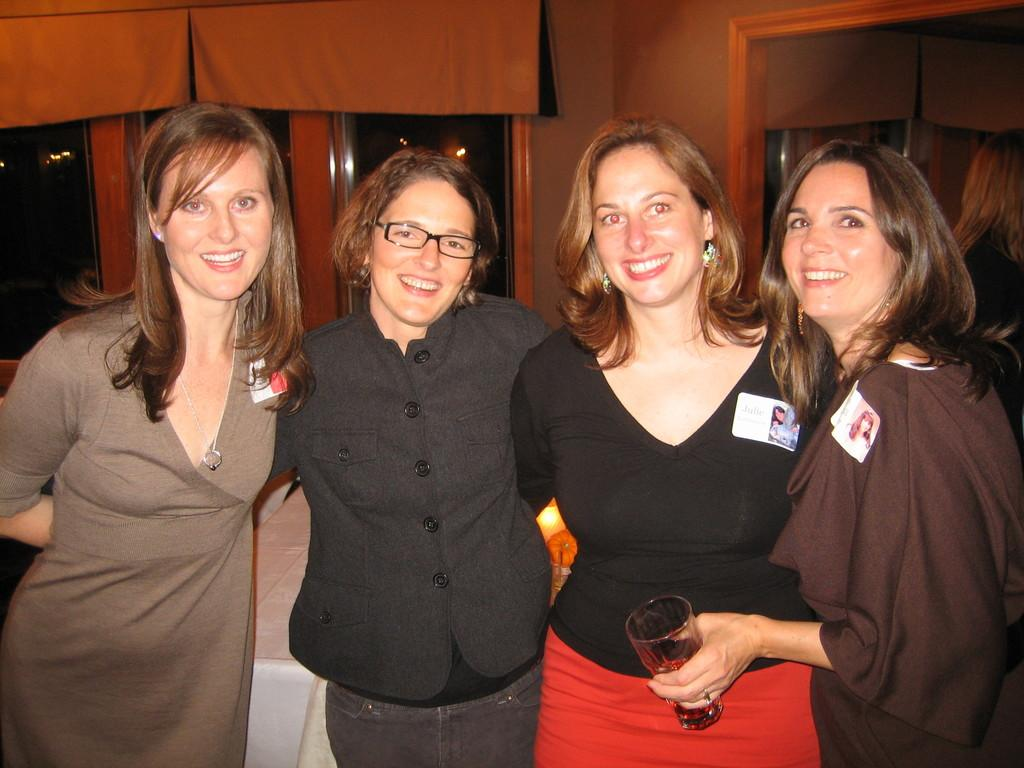How many women are in the image? There are four women in the image. What are the women doing in the image? The women are standing and smiling. What can be seen in the background of the image? There is a glass window and a wall in the background of the image. What type of disease is affecting the women in the image? There is no indication of any disease affecting the women in the image; they are standing and smiling. 